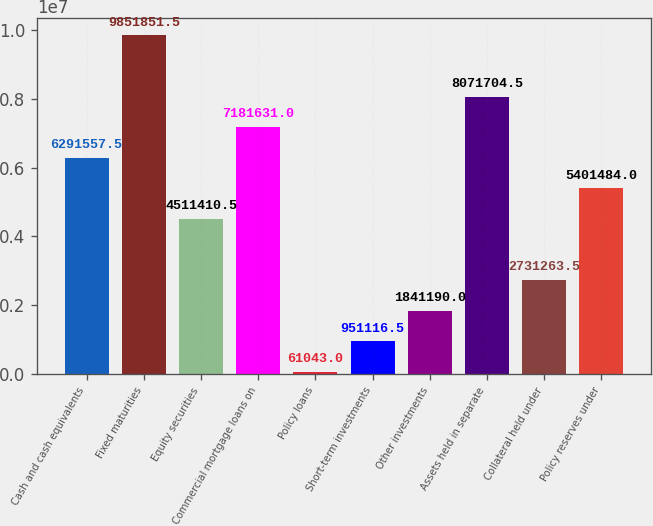Convert chart to OTSL. <chart><loc_0><loc_0><loc_500><loc_500><bar_chart><fcel>Cash and cash equivalents<fcel>Fixed maturities<fcel>Equity securities<fcel>Commercial mortgage loans on<fcel>Policy loans<fcel>Short-term investments<fcel>Other investments<fcel>Assets held in separate<fcel>Collateral held under<fcel>Policy reserves under<nl><fcel>6.29156e+06<fcel>9.85185e+06<fcel>4.51141e+06<fcel>7.18163e+06<fcel>61043<fcel>951116<fcel>1.84119e+06<fcel>8.0717e+06<fcel>2.73126e+06<fcel>5.40148e+06<nl></chart> 